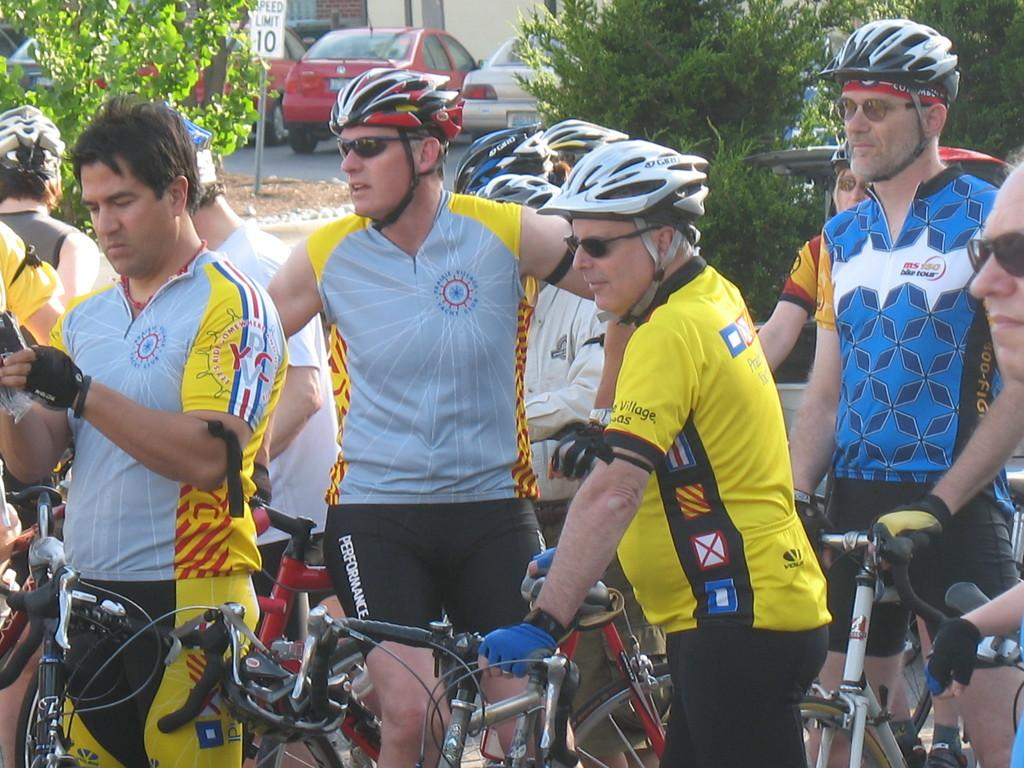How many people are in the image? There is a group of people in the image. What are the people doing in the image? The people are standing on bicycles. What type of vegetation can be seen in the image? There are trees visible in the image. What type of vehicles are present in the image? There are cars present in the image. How many basins are visible in the image? There are no basins present in the image. What type of ray can be seen flying in the image? There are no rays, such as stingrays or manta rays, visible in the image. 